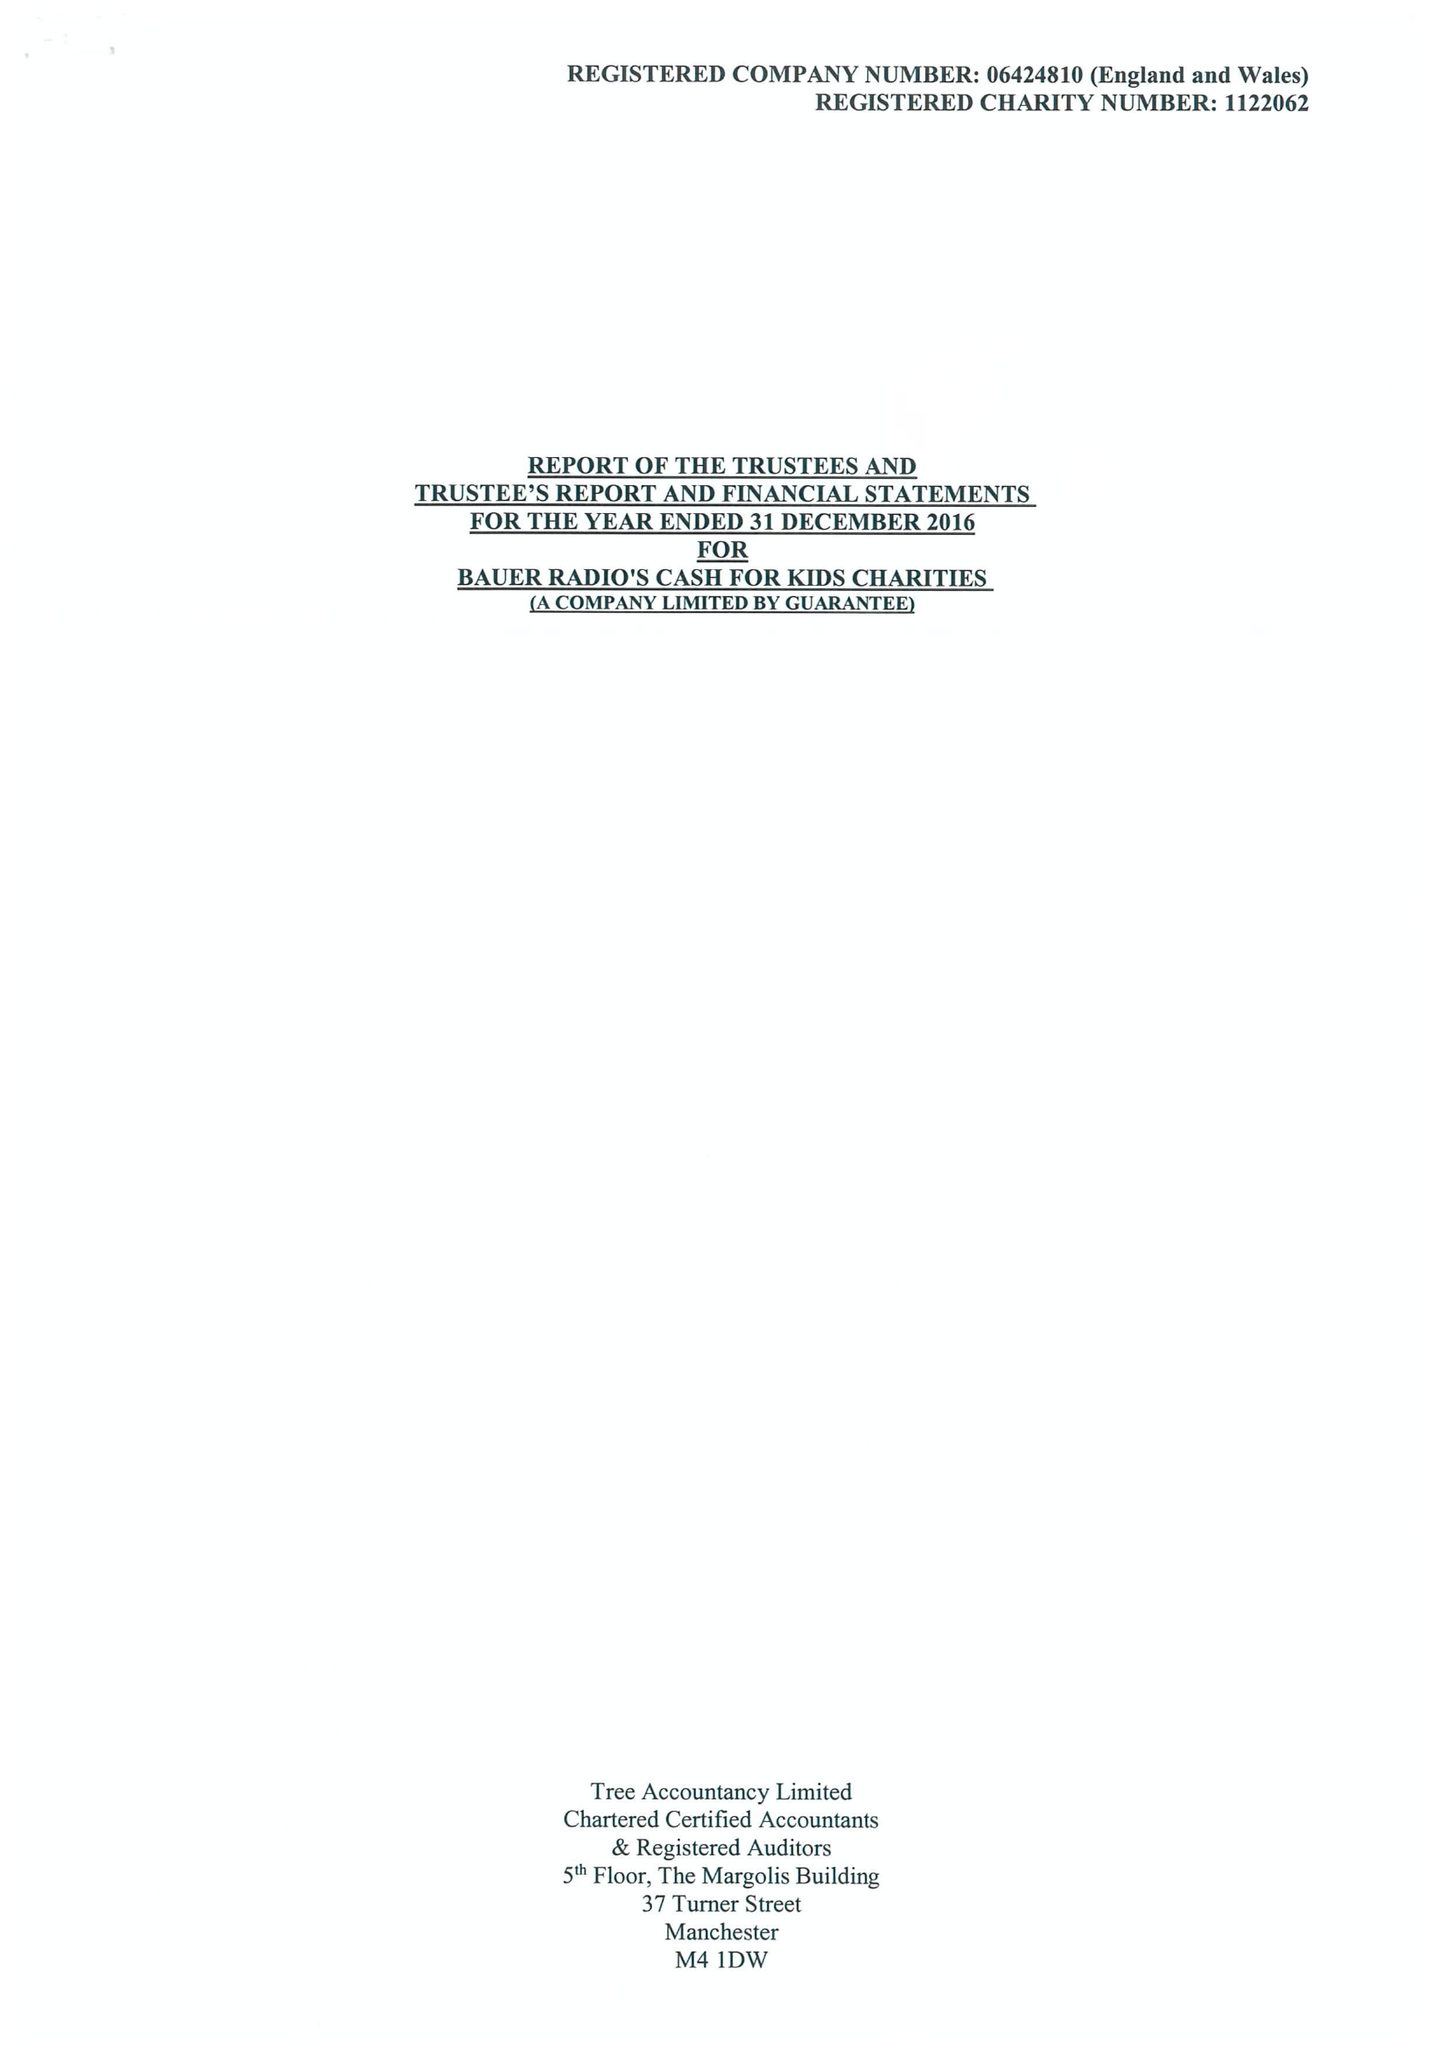What is the value for the address__postcode?
Answer the question using a single word or phrase. TS18 3TS 